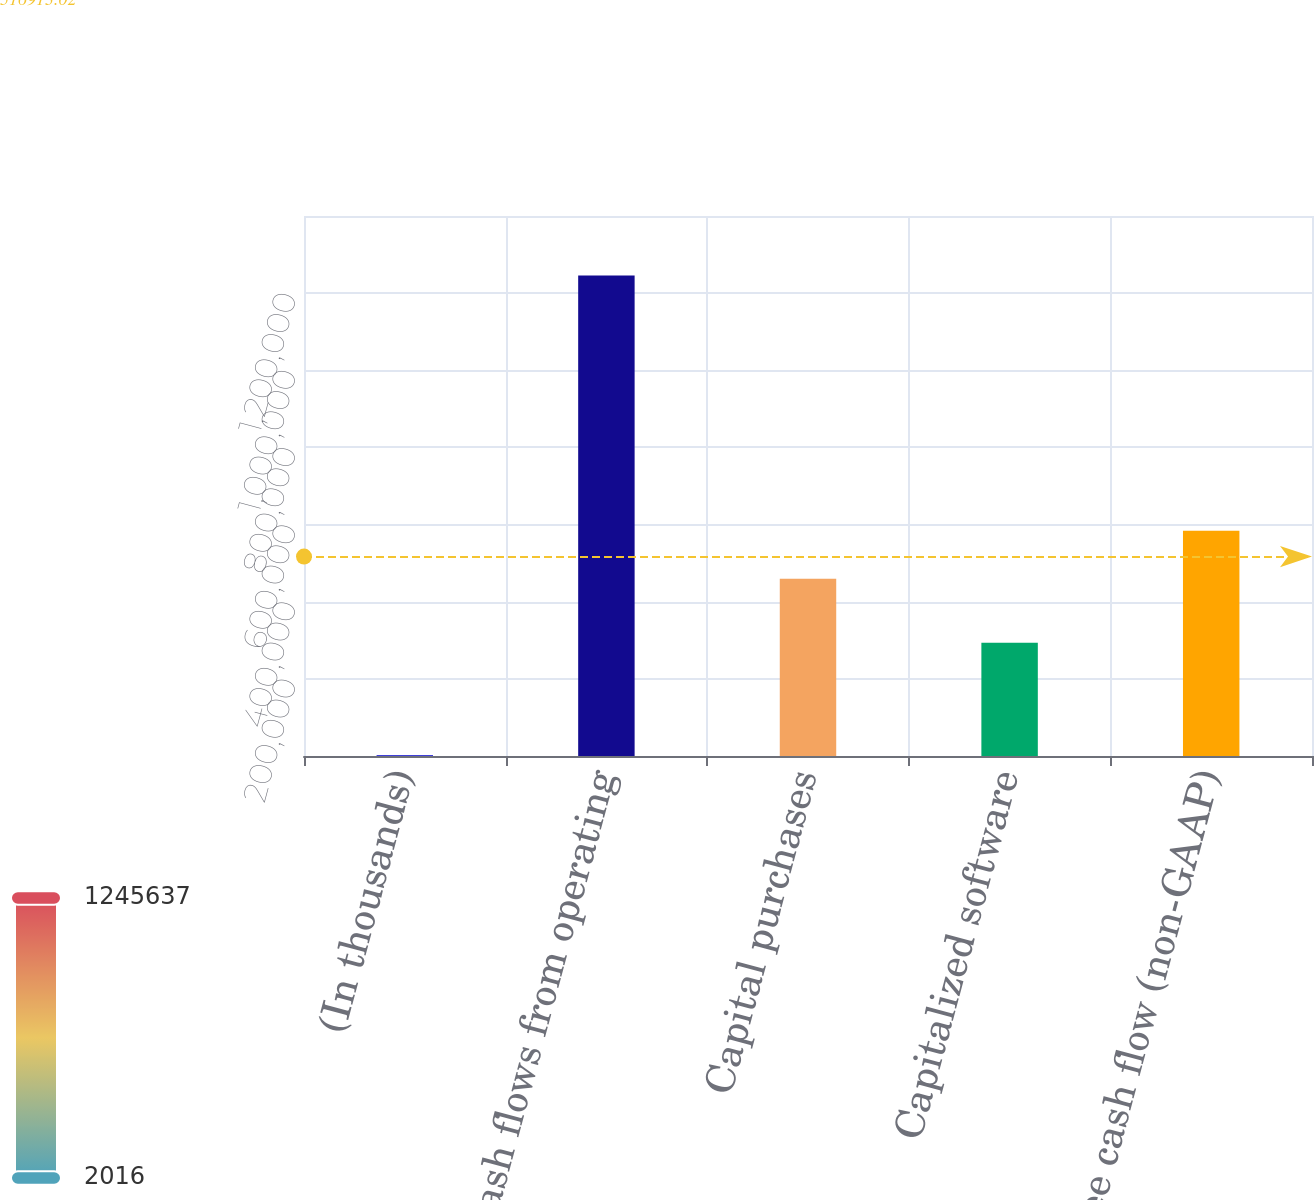Convert chart. <chart><loc_0><loc_0><loc_500><loc_500><bar_chart><fcel>(In thousands)<fcel>Cash flows from operating<fcel>Capital purchases<fcel>Capitalized software<fcel>Free cash flow (non-GAAP)<nl><fcel>2016<fcel>1.24564e+06<fcel>459427<fcel>293696<fcel>583789<nl></chart> 